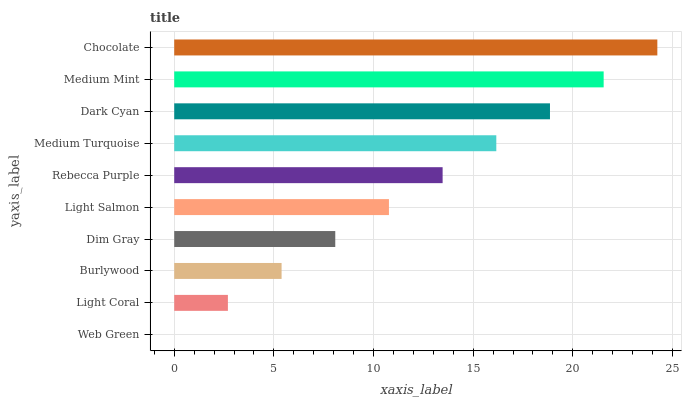Is Web Green the minimum?
Answer yes or no. Yes. Is Chocolate the maximum?
Answer yes or no. Yes. Is Light Coral the minimum?
Answer yes or no. No. Is Light Coral the maximum?
Answer yes or no. No. Is Light Coral greater than Web Green?
Answer yes or no. Yes. Is Web Green less than Light Coral?
Answer yes or no. Yes. Is Web Green greater than Light Coral?
Answer yes or no. No. Is Light Coral less than Web Green?
Answer yes or no. No. Is Rebecca Purple the high median?
Answer yes or no. Yes. Is Light Salmon the low median?
Answer yes or no. Yes. Is Light Coral the high median?
Answer yes or no. No. Is Dim Gray the low median?
Answer yes or no. No. 